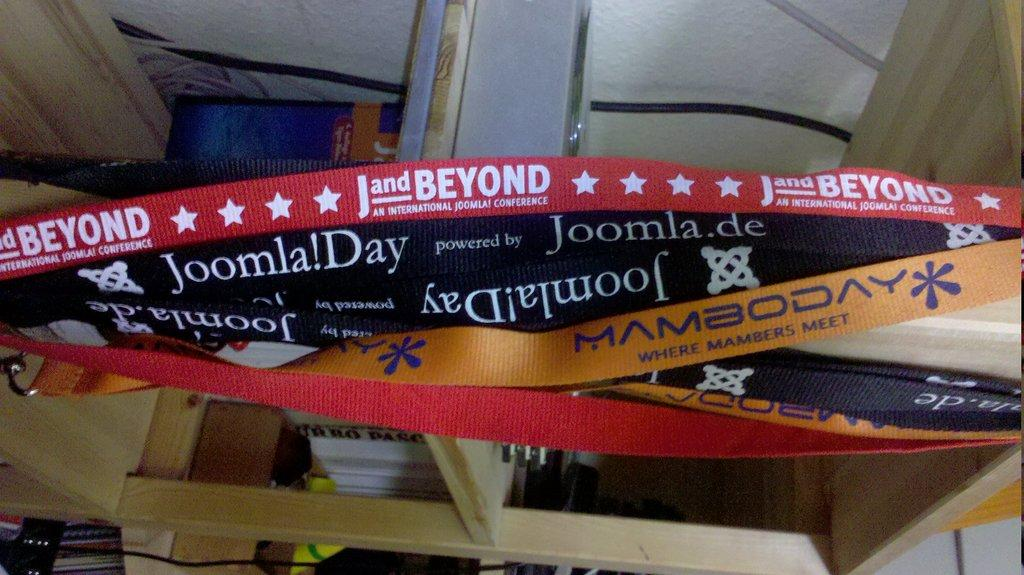<image>
Give a short and clear explanation of the subsequent image. 5 or 6 different streamers with different saying one for example says Joomla! Day. 